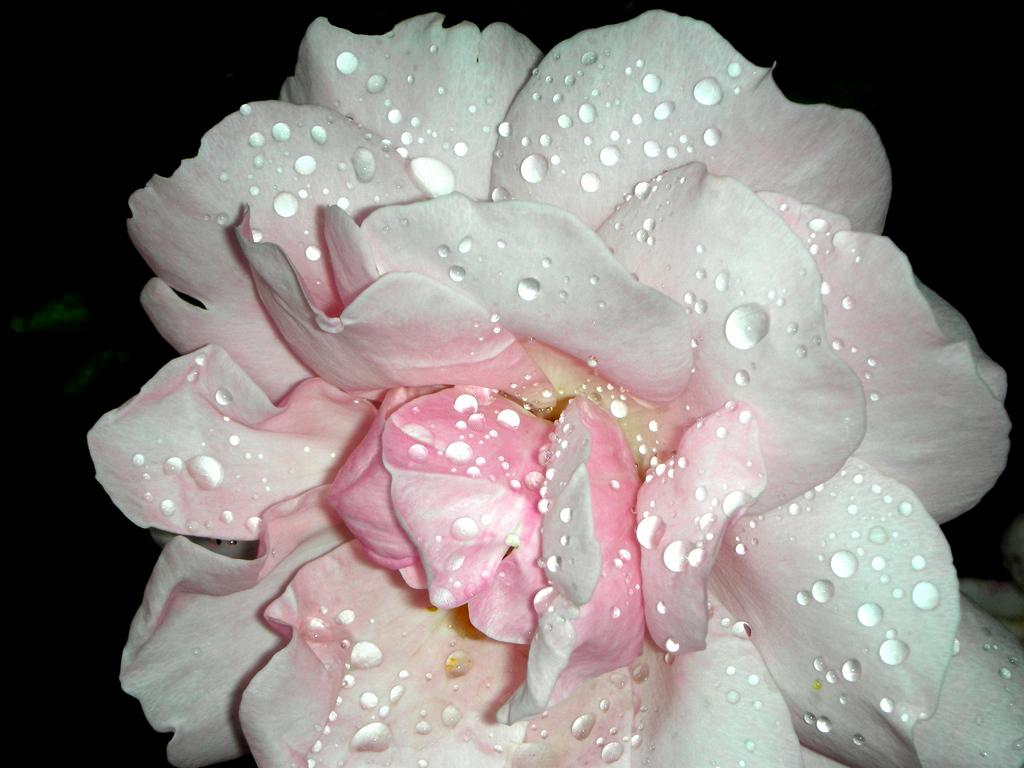What is the main subject of the image? There is a flower in the image. Can you describe the appearance of the flower? There are water drops on the flower. How does the flower push the other flowers in the image? The flower does not push any other flowers in the image, as there is no indication of any other flowers present. 